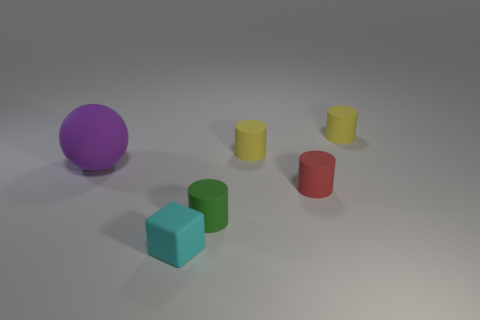What number of cyan objects are either small objects or cubes?
Give a very brief answer. 1. There is a tiny red object; what number of tiny cyan objects are behind it?
Make the answer very short. 0. What is the size of the matte thing behind the tiny yellow matte object in front of the tiny yellow cylinder that is to the right of the tiny red matte cylinder?
Your response must be concise. Small. Are there any yellow things behind the matte thing that is left of the tiny matte object that is in front of the green thing?
Your response must be concise. Yes. Is the number of cyan blocks greater than the number of large cyan rubber cylinders?
Your answer should be very brief. Yes. There is a matte object that is to the left of the cyan rubber cube; what is its color?
Your answer should be compact. Purple. Is the number of tiny matte objects on the right side of the red cylinder greater than the number of large gray cylinders?
Ensure brevity in your answer.  Yes. What number of other objects are there of the same shape as the small green matte thing?
Keep it short and to the point. 3. There is a large rubber sphere that is to the left of the yellow matte object behind the yellow cylinder that is on the left side of the red cylinder; what color is it?
Offer a terse response. Purple. There is a small yellow matte object on the left side of the red matte thing; does it have the same shape as the small red rubber thing?
Provide a short and direct response. Yes. 